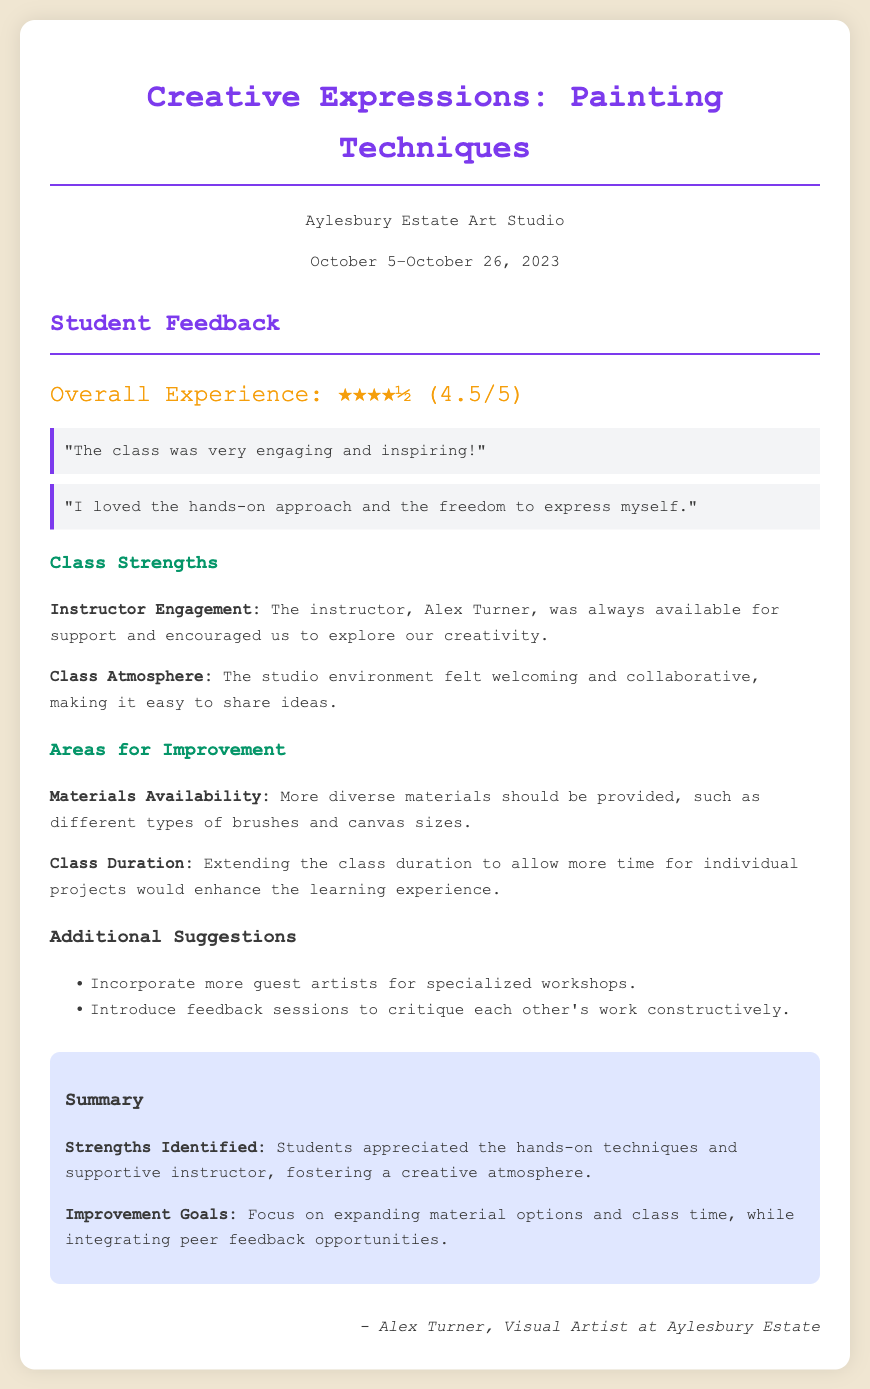what is the title of the document? The title of the document is prominently displayed at the top, which provides the main theme and context of the feedback.
Answer: Creative Expressions: Painting Techniques who was the instructor? The instructor's name is mentioned in the strengths section, highlighting their role in the class.
Answer: Alex Turner what was the overall rating given by the students? The overall rating is shown in a star format, indicating students' satisfaction with the class.
Answer: ★★★★½ (4.5/5) what was one suggested area for improvement? The document lists specific areas that students felt could enhance the class experience, particularly emphasizing materials and class duration.
Answer: Materials Availability how many suggestions for additional improvements were mentioned? The number of suggestions provided can be counted from the additional suggestions section of the document.
Answer: 2 what did students appreciate about the class atmosphere? The strengths section describes the collaborative nature of the environment that students found valuable.
Answer: Welcoming and collaborative what is one suggestion for enhancing the class experience? Suggestions for improvements highlight ideas that could be incorporated into future classes for a better experience.
Answer: Incorporate more guest artists what are the improvement goals listed? The summary section encapsulates the key takeaways and goals for future sessions based on feedback received.
Answer: Expanding material options and class time 